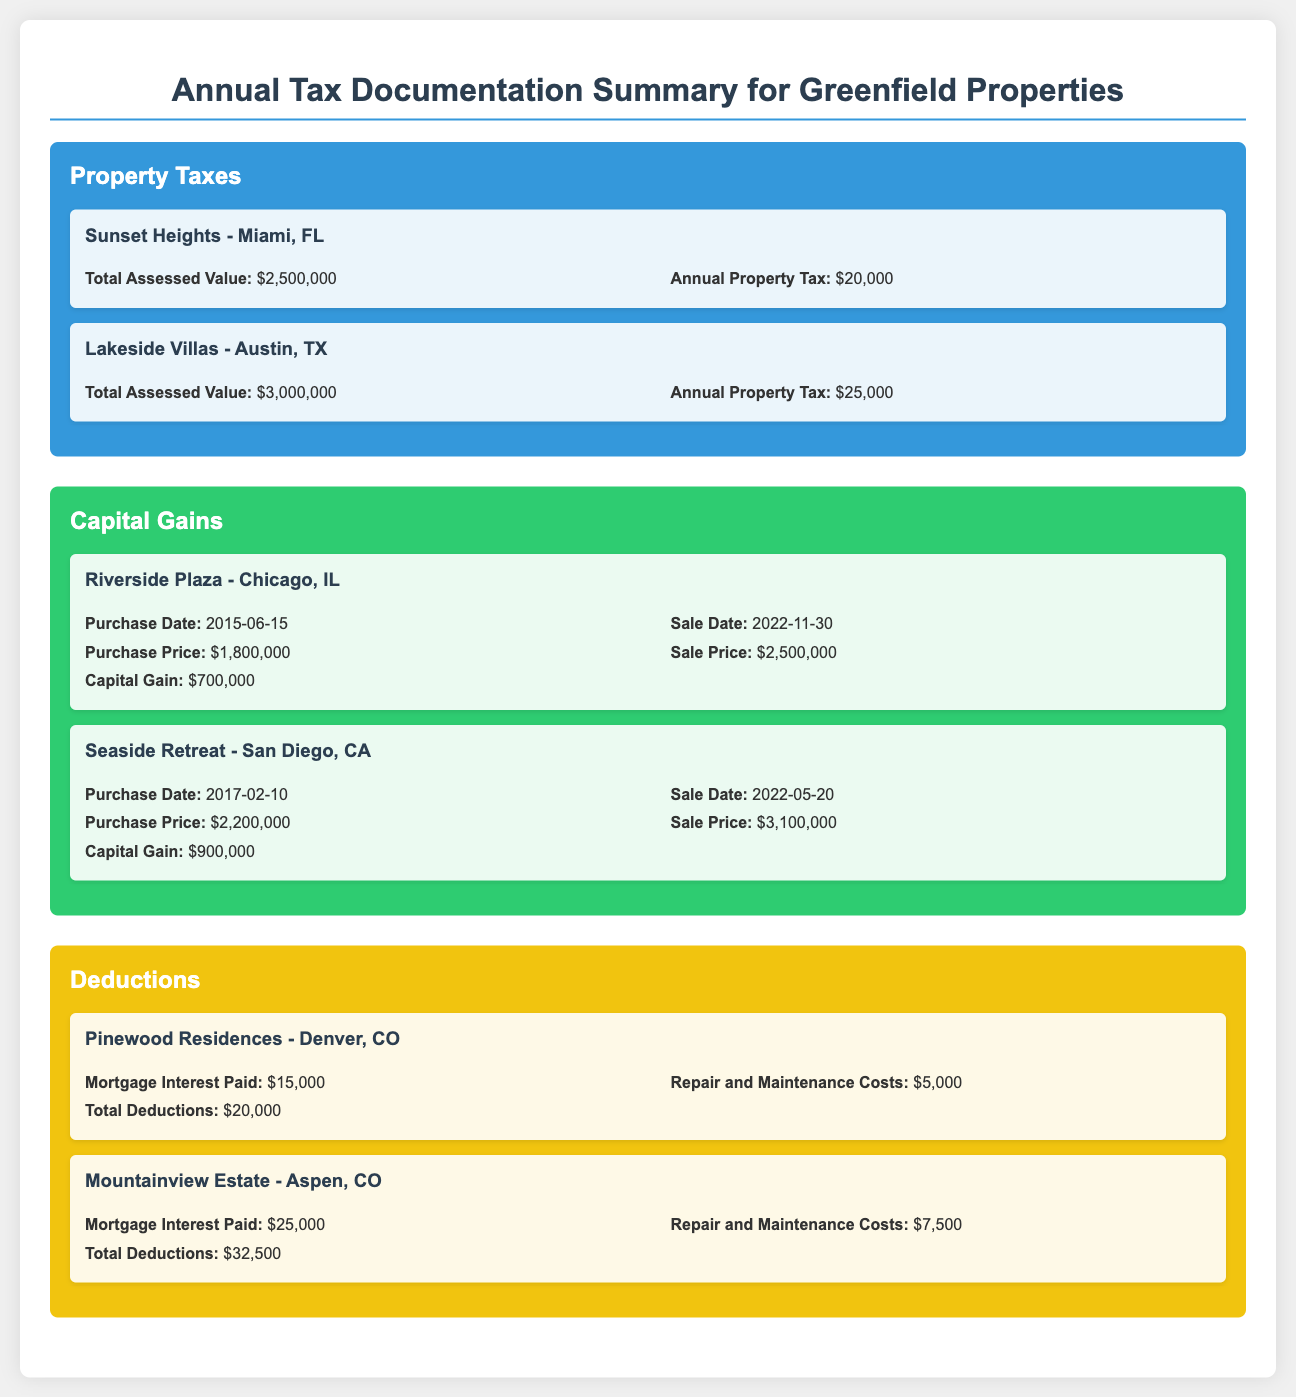What is the annual property tax for Sunset Heights? The annual property tax for Sunset Heights is stated directly in the document as $20,000.
Answer: $20,000 What is the capital gain from the sale of Riverside Plaza? The capital gain is calculated from the sale price minus the purchase price, which is $2,500,000 - $1,800,000 = $700,000.
Answer: $700,000 What are the total deductions for Mountainview Estate? Total deductions for Mountainview Estate are explicitly listed in the document as $32,500.
Answer: $32,500 What is the total assessed value of Lakeside Villas? The total assessed value for Lakeside Villas is mentioned clearly as $3,000,000.
Answer: $3,000,000 Which property had the highest capital gain? The property with the highest capital gain is Seaside Retreat, with a capital gain of $900,000 mentioned in the document.
Answer: Seaside Retreat How much mortgage interest was paid for Pinewood Residences? Mortgage interest paid for Pinewood Residences is recorded in the document as $15,000.
Answer: $15,000 When was Riverside Plaza purchased? Riverside Plaza was purchased on June 15, 2015, according to the purchase date provided in the document.
Answer: 2015-06-15 What is the annual property tax for Lakeside Villas? The annual property tax for Lakeside Villas is specifically identified as $25,000 in the document.
Answer: $25,000 